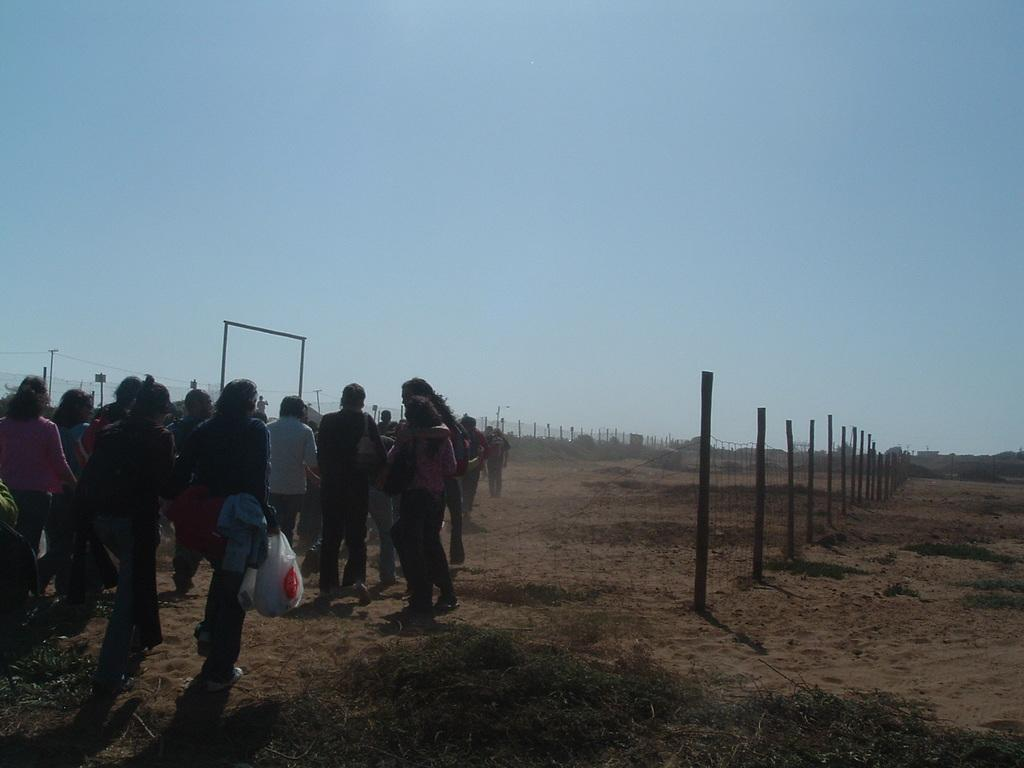Who or what can be seen in the image? There are people in the image. What type of natural environment is present in the image? There is grass in the image. What kind of barrier is visible in the image? There is a fence in the image. What objects are used to cover something in the image? There are plastic covers in the image. What vertical structures can be seen in the image? There are poles in the image. What is visible in the background of the image? The sky is visible in the background of the image. What type of produce is being harvested by the people in the image? There is no produce visible in the image, and the people are not shown harvesting anything. 